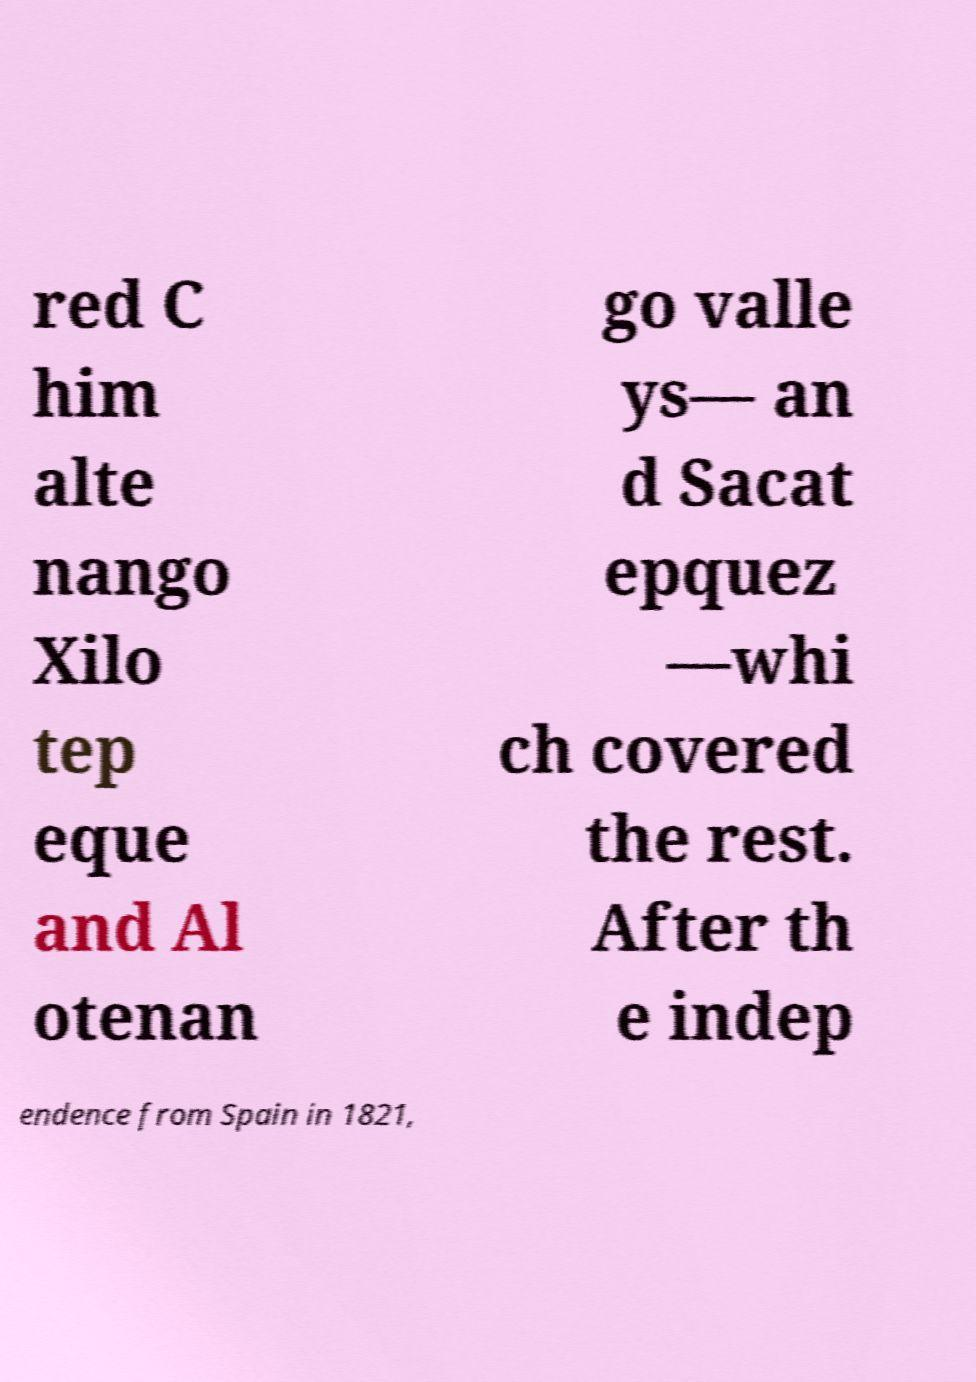Please read and relay the text visible in this image. What does it say? red C him alte nango Xilo tep eque and Al otenan go valle ys— an d Sacat epquez —whi ch covered the rest. After th e indep endence from Spain in 1821, 